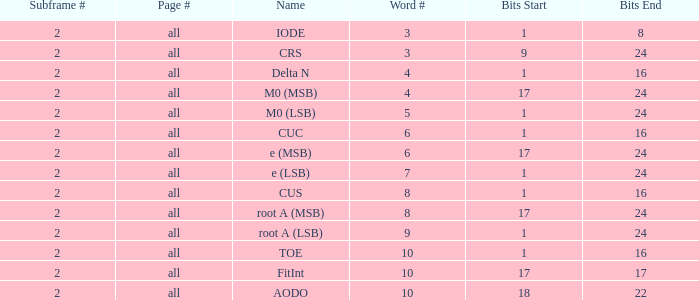What is the total pages and word quantity more than 5 with bits of 18-22? All. Could you help me parse every detail presented in this table? {'header': ['Subframe #', 'Page #', 'Name', 'Word #', 'Bits Start', 'Bits End'], 'rows': [['2', 'all', 'IODE', '3', '1', '8'], ['2', 'all', 'CRS', '3', '9', '24'], ['2', 'all', 'Delta N', '4', '1', '16'], ['2', 'all', 'M0 (MSB)', '4', '17', '24'], ['2', 'all', 'M0 (LSB)', '5', '1', '24'], ['2', 'all', 'CUC', '6', '1', '16'], ['2', 'all', 'e (MSB)', '6', '17', '24'], ['2', 'all', 'e (LSB)', '7', '1', '24'], ['2', 'all', 'CUS', '8', '1', '16'], ['2', 'all', 'root A (MSB)', '8', '17', '24'], ['2', 'all', 'root A (LSB)', '9', '1', '24'], ['2', 'all', 'TOE', '10', '1', '16'], ['2', 'all', 'FitInt', '10', '17', '17'], ['2', 'all', 'AODO', '10', '18', '22']]} 